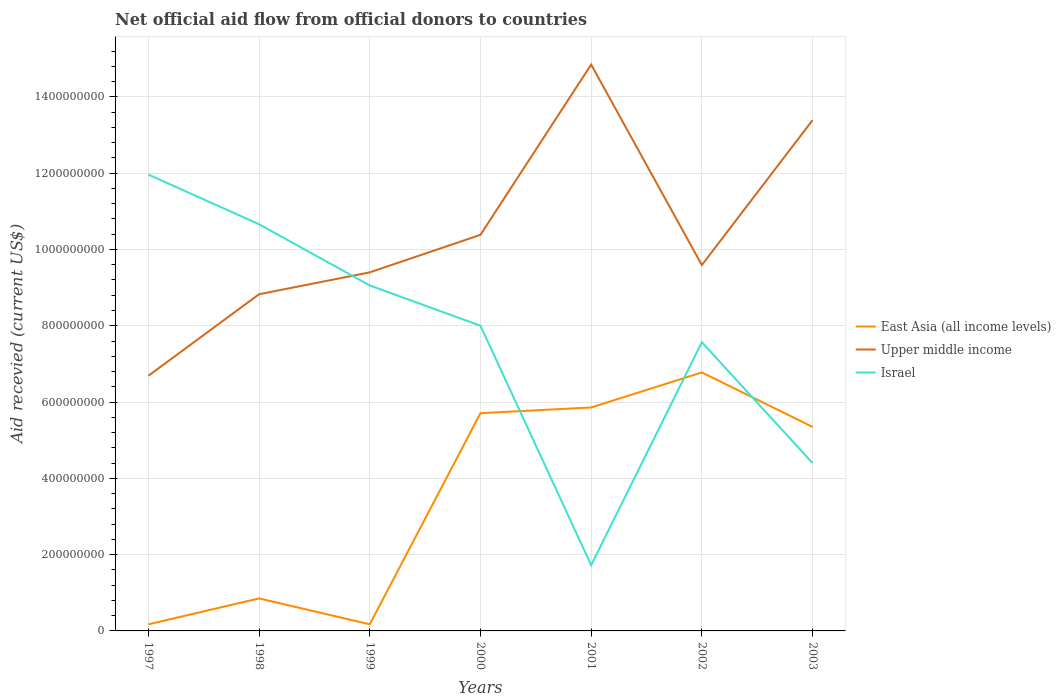How many different coloured lines are there?
Give a very brief answer. 3. Does the line corresponding to East Asia (all income levels) intersect with the line corresponding to Upper middle income?
Offer a terse response. No. Across all years, what is the maximum total aid received in Upper middle income?
Your answer should be very brief. 6.69e+08. What is the total total aid received in East Asia (all income levels) in the graph?
Give a very brief answer. -5.18e+08. What is the difference between the highest and the second highest total aid received in Upper middle income?
Offer a very short reply. 8.16e+08. What is the difference between the highest and the lowest total aid received in East Asia (all income levels)?
Your answer should be compact. 4. How many years are there in the graph?
Give a very brief answer. 7. What is the difference between two consecutive major ticks on the Y-axis?
Make the answer very short. 2.00e+08. Are the values on the major ticks of Y-axis written in scientific E-notation?
Offer a very short reply. No. Where does the legend appear in the graph?
Provide a succinct answer. Center right. What is the title of the graph?
Offer a very short reply. Net official aid flow from official donors to countries. Does "Haiti" appear as one of the legend labels in the graph?
Your answer should be compact. No. What is the label or title of the X-axis?
Give a very brief answer. Years. What is the label or title of the Y-axis?
Your answer should be compact. Aid recevied (current US$). What is the Aid recevied (current US$) of East Asia (all income levels) in 1997?
Keep it short and to the point. 1.73e+07. What is the Aid recevied (current US$) of Upper middle income in 1997?
Provide a succinct answer. 6.69e+08. What is the Aid recevied (current US$) in Israel in 1997?
Ensure brevity in your answer.  1.20e+09. What is the Aid recevied (current US$) of East Asia (all income levels) in 1998?
Ensure brevity in your answer.  8.52e+07. What is the Aid recevied (current US$) in Upper middle income in 1998?
Provide a succinct answer. 8.83e+08. What is the Aid recevied (current US$) of Israel in 1998?
Keep it short and to the point. 1.07e+09. What is the Aid recevied (current US$) of East Asia (all income levels) in 1999?
Keep it short and to the point. 1.74e+07. What is the Aid recevied (current US$) in Upper middle income in 1999?
Provide a short and direct response. 9.40e+08. What is the Aid recevied (current US$) of Israel in 1999?
Ensure brevity in your answer.  9.06e+08. What is the Aid recevied (current US$) in East Asia (all income levels) in 2000?
Give a very brief answer. 5.71e+08. What is the Aid recevied (current US$) of Upper middle income in 2000?
Your response must be concise. 1.04e+09. What is the Aid recevied (current US$) of Israel in 2000?
Make the answer very short. 8.00e+08. What is the Aid recevied (current US$) in East Asia (all income levels) in 2001?
Provide a short and direct response. 5.86e+08. What is the Aid recevied (current US$) in Upper middle income in 2001?
Provide a succinct answer. 1.48e+09. What is the Aid recevied (current US$) of Israel in 2001?
Your answer should be very brief. 1.72e+08. What is the Aid recevied (current US$) of East Asia (all income levels) in 2002?
Your response must be concise. 6.78e+08. What is the Aid recevied (current US$) in Upper middle income in 2002?
Ensure brevity in your answer.  9.59e+08. What is the Aid recevied (current US$) of Israel in 2002?
Your answer should be compact. 7.57e+08. What is the Aid recevied (current US$) in East Asia (all income levels) in 2003?
Provide a succinct answer. 5.35e+08. What is the Aid recevied (current US$) of Upper middle income in 2003?
Make the answer very short. 1.34e+09. What is the Aid recevied (current US$) of Israel in 2003?
Your answer should be very brief. 4.40e+08. Across all years, what is the maximum Aid recevied (current US$) in East Asia (all income levels)?
Offer a very short reply. 6.78e+08. Across all years, what is the maximum Aid recevied (current US$) in Upper middle income?
Offer a terse response. 1.48e+09. Across all years, what is the maximum Aid recevied (current US$) in Israel?
Keep it short and to the point. 1.20e+09. Across all years, what is the minimum Aid recevied (current US$) of East Asia (all income levels)?
Provide a succinct answer. 1.73e+07. Across all years, what is the minimum Aid recevied (current US$) in Upper middle income?
Provide a short and direct response. 6.69e+08. Across all years, what is the minimum Aid recevied (current US$) in Israel?
Your answer should be very brief. 1.72e+08. What is the total Aid recevied (current US$) in East Asia (all income levels) in the graph?
Your answer should be compact. 2.49e+09. What is the total Aid recevied (current US$) in Upper middle income in the graph?
Give a very brief answer. 7.31e+09. What is the total Aid recevied (current US$) in Israel in the graph?
Provide a succinct answer. 5.34e+09. What is the difference between the Aid recevied (current US$) in East Asia (all income levels) in 1997 and that in 1998?
Your response must be concise. -6.80e+07. What is the difference between the Aid recevied (current US$) of Upper middle income in 1997 and that in 1998?
Offer a very short reply. -2.14e+08. What is the difference between the Aid recevied (current US$) in Israel in 1997 and that in 1998?
Your response must be concise. 1.30e+08. What is the difference between the Aid recevied (current US$) of East Asia (all income levels) in 1997 and that in 1999?
Provide a short and direct response. -6.00e+04. What is the difference between the Aid recevied (current US$) in Upper middle income in 1997 and that in 1999?
Make the answer very short. -2.71e+08. What is the difference between the Aid recevied (current US$) in Israel in 1997 and that in 1999?
Offer a very short reply. 2.91e+08. What is the difference between the Aid recevied (current US$) of East Asia (all income levels) in 1997 and that in 2000?
Give a very brief answer. -5.54e+08. What is the difference between the Aid recevied (current US$) in Upper middle income in 1997 and that in 2000?
Give a very brief answer. -3.69e+08. What is the difference between the Aid recevied (current US$) in Israel in 1997 and that in 2000?
Offer a terse response. 3.96e+08. What is the difference between the Aid recevied (current US$) in East Asia (all income levels) in 1997 and that in 2001?
Ensure brevity in your answer.  -5.69e+08. What is the difference between the Aid recevied (current US$) of Upper middle income in 1997 and that in 2001?
Your response must be concise. -8.16e+08. What is the difference between the Aid recevied (current US$) in Israel in 1997 and that in 2001?
Provide a succinct answer. 1.02e+09. What is the difference between the Aid recevied (current US$) in East Asia (all income levels) in 1997 and that in 2002?
Make the answer very short. -6.60e+08. What is the difference between the Aid recevied (current US$) of Upper middle income in 1997 and that in 2002?
Offer a very short reply. -2.90e+08. What is the difference between the Aid recevied (current US$) in Israel in 1997 and that in 2002?
Offer a terse response. 4.39e+08. What is the difference between the Aid recevied (current US$) of East Asia (all income levels) in 1997 and that in 2003?
Keep it short and to the point. -5.18e+08. What is the difference between the Aid recevied (current US$) in Upper middle income in 1997 and that in 2003?
Offer a terse response. -6.70e+08. What is the difference between the Aid recevied (current US$) of Israel in 1997 and that in 2003?
Your response must be concise. 7.56e+08. What is the difference between the Aid recevied (current US$) in East Asia (all income levels) in 1998 and that in 1999?
Your answer should be very brief. 6.79e+07. What is the difference between the Aid recevied (current US$) in Upper middle income in 1998 and that in 1999?
Your response must be concise. -5.73e+07. What is the difference between the Aid recevied (current US$) of Israel in 1998 and that in 1999?
Your answer should be compact. 1.60e+08. What is the difference between the Aid recevied (current US$) in East Asia (all income levels) in 1998 and that in 2000?
Make the answer very short. -4.86e+08. What is the difference between the Aid recevied (current US$) in Upper middle income in 1998 and that in 2000?
Offer a terse response. -1.56e+08. What is the difference between the Aid recevied (current US$) in Israel in 1998 and that in 2000?
Make the answer very short. 2.66e+08. What is the difference between the Aid recevied (current US$) in East Asia (all income levels) in 1998 and that in 2001?
Provide a succinct answer. -5.01e+08. What is the difference between the Aid recevied (current US$) in Upper middle income in 1998 and that in 2001?
Your response must be concise. -6.02e+08. What is the difference between the Aid recevied (current US$) in Israel in 1998 and that in 2001?
Your response must be concise. 8.94e+08. What is the difference between the Aid recevied (current US$) of East Asia (all income levels) in 1998 and that in 2002?
Your answer should be very brief. -5.92e+08. What is the difference between the Aid recevied (current US$) of Upper middle income in 1998 and that in 2002?
Provide a short and direct response. -7.64e+07. What is the difference between the Aid recevied (current US$) of Israel in 1998 and that in 2002?
Give a very brief answer. 3.09e+08. What is the difference between the Aid recevied (current US$) in East Asia (all income levels) in 1998 and that in 2003?
Make the answer very short. -4.50e+08. What is the difference between the Aid recevied (current US$) in Upper middle income in 1998 and that in 2003?
Provide a short and direct response. -4.56e+08. What is the difference between the Aid recevied (current US$) of Israel in 1998 and that in 2003?
Your response must be concise. 6.26e+08. What is the difference between the Aid recevied (current US$) in East Asia (all income levels) in 1999 and that in 2000?
Your response must be concise. -5.53e+08. What is the difference between the Aid recevied (current US$) in Upper middle income in 1999 and that in 2000?
Give a very brief answer. -9.83e+07. What is the difference between the Aid recevied (current US$) in Israel in 1999 and that in 2000?
Provide a succinct answer. 1.06e+08. What is the difference between the Aid recevied (current US$) of East Asia (all income levels) in 1999 and that in 2001?
Offer a terse response. -5.68e+08. What is the difference between the Aid recevied (current US$) of Upper middle income in 1999 and that in 2001?
Your answer should be compact. -5.45e+08. What is the difference between the Aid recevied (current US$) in Israel in 1999 and that in 2001?
Offer a very short reply. 7.33e+08. What is the difference between the Aid recevied (current US$) in East Asia (all income levels) in 1999 and that in 2002?
Provide a succinct answer. -6.60e+08. What is the difference between the Aid recevied (current US$) of Upper middle income in 1999 and that in 2002?
Offer a terse response. -1.91e+07. What is the difference between the Aid recevied (current US$) of Israel in 1999 and that in 2002?
Your answer should be very brief. 1.49e+08. What is the difference between the Aid recevied (current US$) of East Asia (all income levels) in 1999 and that in 2003?
Keep it short and to the point. -5.18e+08. What is the difference between the Aid recevied (current US$) in Upper middle income in 1999 and that in 2003?
Make the answer very short. -3.99e+08. What is the difference between the Aid recevied (current US$) of Israel in 1999 and that in 2003?
Make the answer very short. 4.66e+08. What is the difference between the Aid recevied (current US$) in East Asia (all income levels) in 2000 and that in 2001?
Your response must be concise. -1.50e+07. What is the difference between the Aid recevied (current US$) in Upper middle income in 2000 and that in 2001?
Offer a very short reply. -4.46e+08. What is the difference between the Aid recevied (current US$) of Israel in 2000 and that in 2001?
Provide a succinct answer. 6.28e+08. What is the difference between the Aid recevied (current US$) in East Asia (all income levels) in 2000 and that in 2002?
Ensure brevity in your answer.  -1.07e+08. What is the difference between the Aid recevied (current US$) in Upper middle income in 2000 and that in 2002?
Offer a very short reply. 7.93e+07. What is the difference between the Aid recevied (current US$) in Israel in 2000 and that in 2002?
Offer a terse response. 4.31e+07. What is the difference between the Aid recevied (current US$) in East Asia (all income levels) in 2000 and that in 2003?
Ensure brevity in your answer.  3.59e+07. What is the difference between the Aid recevied (current US$) of Upper middle income in 2000 and that in 2003?
Make the answer very short. -3.01e+08. What is the difference between the Aid recevied (current US$) of Israel in 2000 and that in 2003?
Give a very brief answer. 3.60e+08. What is the difference between the Aid recevied (current US$) of East Asia (all income levels) in 2001 and that in 2002?
Make the answer very short. -9.18e+07. What is the difference between the Aid recevied (current US$) of Upper middle income in 2001 and that in 2002?
Provide a short and direct response. 5.26e+08. What is the difference between the Aid recevied (current US$) of Israel in 2001 and that in 2002?
Give a very brief answer. -5.85e+08. What is the difference between the Aid recevied (current US$) in East Asia (all income levels) in 2001 and that in 2003?
Offer a very short reply. 5.10e+07. What is the difference between the Aid recevied (current US$) in Upper middle income in 2001 and that in 2003?
Keep it short and to the point. 1.46e+08. What is the difference between the Aid recevied (current US$) in Israel in 2001 and that in 2003?
Your answer should be compact. -2.68e+08. What is the difference between the Aid recevied (current US$) in East Asia (all income levels) in 2002 and that in 2003?
Your answer should be compact. 1.43e+08. What is the difference between the Aid recevied (current US$) of Upper middle income in 2002 and that in 2003?
Your answer should be compact. -3.80e+08. What is the difference between the Aid recevied (current US$) of Israel in 2002 and that in 2003?
Your response must be concise. 3.17e+08. What is the difference between the Aid recevied (current US$) of East Asia (all income levels) in 1997 and the Aid recevied (current US$) of Upper middle income in 1998?
Provide a short and direct response. -8.65e+08. What is the difference between the Aid recevied (current US$) in East Asia (all income levels) in 1997 and the Aid recevied (current US$) in Israel in 1998?
Give a very brief answer. -1.05e+09. What is the difference between the Aid recevied (current US$) of Upper middle income in 1997 and the Aid recevied (current US$) of Israel in 1998?
Your answer should be very brief. -3.97e+08. What is the difference between the Aid recevied (current US$) of East Asia (all income levels) in 1997 and the Aid recevied (current US$) of Upper middle income in 1999?
Provide a succinct answer. -9.23e+08. What is the difference between the Aid recevied (current US$) in East Asia (all income levels) in 1997 and the Aid recevied (current US$) in Israel in 1999?
Your answer should be compact. -8.88e+08. What is the difference between the Aid recevied (current US$) of Upper middle income in 1997 and the Aid recevied (current US$) of Israel in 1999?
Ensure brevity in your answer.  -2.37e+08. What is the difference between the Aid recevied (current US$) of East Asia (all income levels) in 1997 and the Aid recevied (current US$) of Upper middle income in 2000?
Keep it short and to the point. -1.02e+09. What is the difference between the Aid recevied (current US$) of East Asia (all income levels) in 1997 and the Aid recevied (current US$) of Israel in 2000?
Give a very brief answer. -7.83e+08. What is the difference between the Aid recevied (current US$) in Upper middle income in 1997 and the Aid recevied (current US$) in Israel in 2000?
Ensure brevity in your answer.  -1.31e+08. What is the difference between the Aid recevied (current US$) of East Asia (all income levels) in 1997 and the Aid recevied (current US$) of Upper middle income in 2001?
Offer a terse response. -1.47e+09. What is the difference between the Aid recevied (current US$) in East Asia (all income levels) in 1997 and the Aid recevied (current US$) in Israel in 2001?
Give a very brief answer. -1.55e+08. What is the difference between the Aid recevied (current US$) in Upper middle income in 1997 and the Aid recevied (current US$) in Israel in 2001?
Provide a short and direct response. 4.97e+08. What is the difference between the Aid recevied (current US$) of East Asia (all income levels) in 1997 and the Aid recevied (current US$) of Upper middle income in 2002?
Keep it short and to the point. -9.42e+08. What is the difference between the Aid recevied (current US$) of East Asia (all income levels) in 1997 and the Aid recevied (current US$) of Israel in 2002?
Keep it short and to the point. -7.40e+08. What is the difference between the Aid recevied (current US$) in Upper middle income in 1997 and the Aid recevied (current US$) in Israel in 2002?
Your response must be concise. -8.79e+07. What is the difference between the Aid recevied (current US$) in East Asia (all income levels) in 1997 and the Aid recevied (current US$) in Upper middle income in 2003?
Ensure brevity in your answer.  -1.32e+09. What is the difference between the Aid recevied (current US$) of East Asia (all income levels) in 1997 and the Aid recevied (current US$) of Israel in 2003?
Your response must be concise. -4.23e+08. What is the difference between the Aid recevied (current US$) of Upper middle income in 1997 and the Aid recevied (current US$) of Israel in 2003?
Offer a very short reply. 2.29e+08. What is the difference between the Aid recevied (current US$) of East Asia (all income levels) in 1998 and the Aid recevied (current US$) of Upper middle income in 1999?
Your answer should be compact. -8.55e+08. What is the difference between the Aid recevied (current US$) in East Asia (all income levels) in 1998 and the Aid recevied (current US$) in Israel in 1999?
Offer a terse response. -8.20e+08. What is the difference between the Aid recevied (current US$) of Upper middle income in 1998 and the Aid recevied (current US$) of Israel in 1999?
Offer a very short reply. -2.31e+07. What is the difference between the Aid recevied (current US$) of East Asia (all income levels) in 1998 and the Aid recevied (current US$) of Upper middle income in 2000?
Your answer should be very brief. -9.53e+08. What is the difference between the Aid recevied (current US$) of East Asia (all income levels) in 1998 and the Aid recevied (current US$) of Israel in 2000?
Provide a succinct answer. -7.15e+08. What is the difference between the Aid recevied (current US$) in Upper middle income in 1998 and the Aid recevied (current US$) in Israel in 2000?
Provide a succinct answer. 8.26e+07. What is the difference between the Aid recevied (current US$) in East Asia (all income levels) in 1998 and the Aid recevied (current US$) in Upper middle income in 2001?
Offer a terse response. -1.40e+09. What is the difference between the Aid recevied (current US$) of East Asia (all income levels) in 1998 and the Aid recevied (current US$) of Israel in 2001?
Your answer should be very brief. -8.71e+07. What is the difference between the Aid recevied (current US$) of Upper middle income in 1998 and the Aid recevied (current US$) of Israel in 2001?
Your answer should be compact. 7.10e+08. What is the difference between the Aid recevied (current US$) in East Asia (all income levels) in 1998 and the Aid recevied (current US$) in Upper middle income in 2002?
Provide a succinct answer. -8.74e+08. What is the difference between the Aid recevied (current US$) of East Asia (all income levels) in 1998 and the Aid recevied (current US$) of Israel in 2002?
Keep it short and to the point. -6.72e+08. What is the difference between the Aid recevied (current US$) in Upper middle income in 1998 and the Aid recevied (current US$) in Israel in 2002?
Give a very brief answer. 1.26e+08. What is the difference between the Aid recevied (current US$) of East Asia (all income levels) in 1998 and the Aid recevied (current US$) of Upper middle income in 2003?
Keep it short and to the point. -1.25e+09. What is the difference between the Aid recevied (current US$) of East Asia (all income levels) in 1998 and the Aid recevied (current US$) of Israel in 2003?
Your response must be concise. -3.55e+08. What is the difference between the Aid recevied (current US$) of Upper middle income in 1998 and the Aid recevied (current US$) of Israel in 2003?
Provide a succinct answer. 4.43e+08. What is the difference between the Aid recevied (current US$) of East Asia (all income levels) in 1999 and the Aid recevied (current US$) of Upper middle income in 2000?
Ensure brevity in your answer.  -1.02e+09. What is the difference between the Aid recevied (current US$) of East Asia (all income levels) in 1999 and the Aid recevied (current US$) of Israel in 2000?
Give a very brief answer. -7.83e+08. What is the difference between the Aid recevied (current US$) of Upper middle income in 1999 and the Aid recevied (current US$) of Israel in 2000?
Make the answer very short. 1.40e+08. What is the difference between the Aid recevied (current US$) of East Asia (all income levels) in 1999 and the Aid recevied (current US$) of Upper middle income in 2001?
Keep it short and to the point. -1.47e+09. What is the difference between the Aid recevied (current US$) in East Asia (all income levels) in 1999 and the Aid recevied (current US$) in Israel in 2001?
Your response must be concise. -1.55e+08. What is the difference between the Aid recevied (current US$) in Upper middle income in 1999 and the Aid recevied (current US$) in Israel in 2001?
Provide a succinct answer. 7.68e+08. What is the difference between the Aid recevied (current US$) of East Asia (all income levels) in 1999 and the Aid recevied (current US$) of Upper middle income in 2002?
Make the answer very short. -9.42e+08. What is the difference between the Aid recevied (current US$) of East Asia (all income levels) in 1999 and the Aid recevied (current US$) of Israel in 2002?
Give a very brief answer. -7.40e+08. What is the difference between the Aid recevied (current US$) of Upper middle income in 1999 and the Aid recevied (current US$) of Israel in 2002?
Your answer should be compact. 1.83e+08. What is the difference between the Aid recevied (current US$) in East Asia (all income levels) in 1999 and the Aid recevied (current US$) in Upper middle income in 2003?
Offer a very short reply. -1.32e+09. What is the difference between the Aid recevied (current US$) in East Asia (all income levels) in 1999 and the Aid recevied (current US$) in Israel in 2003?
Your response must be concise. -4.23e+08. What is the difference between the Aid recevied (current US$) in Upper middle income in 1999 and the Aid recevied (current US$) in Israel in 2003?
Make the answer very short. 5.00e+08. What is the difference between the Aid recevied (current US$) in East Asia (all income levels) in 2000 and the Aid recevied (current US$) in Upper middle income in 2001?
Your answer should be very brief. -9.14e+08. What is the difference between the Aid recevied (current US$) in East Asia (all income levels) in 2000 and the Aid recevied (current US$) in Israel in 2001?
Offer a very short reply. 3.98e+08. What is the difference between the Aid recevied (current US$) of Upper middle income in 2000 and the Aid recevied (current US$) of Israel in 2001?
Your answer should be very brief. 8.66e+08. What is the difference between the Aid recevied (current US$) of East Asia (all income levels) in 2000 and the Aid recevied (current US$) of Upper middle income in 2002?
Ensure brevity in your answer.  -3.88e+08. What is the difference between the Aid recevied (current US$) of East Asia (all income levels) in 2000 and the Aid recevied (current US$) of Israel in 2002?
Your answer should be compact. -1.86e+08. What is the difference between the Aid recevied (current US$) in Upper middle income in 2000 and the Aid recevied (current US$) in Israel in 2002?
Make the answer very short. 2.81e+08. What is the difference between the Aid recevied (current US$) in East Asia (all income levels) in 2000 and the Aid recevied (current US$) in Upper middle income in 2003?
Provide a short and direct response. -7.68e+08. What is the difference between the Aid recevied (current US$) in East Asia (all income levels) in 2000 and the Aid recevied (current US$) in Israel in 2003?
Offer a very short reply. 1.31e+08. What is the difference between the Aid recevied (current US$) in Upper middle income in 2000 and the Aid recevied (current US$) in Israel in 2003?
Provide a short and direct response. 5.98e+08. What is the difference between the Aid recevied (current US$) of East Asia (all income levels) in 2001 and the Aid recevied (current US$) of Upper middle income in 2002?
Give a very brief answer. -3.73e+08. What is the difference between the Aid recevied (current US$) in East Asia (all income levels) in 2001 and the Aid recevied (current US$) in Israel in 2002?
Give a very brief answer. -1.71e+08. What is the difference between the Aid recevied (current US$) in Upper middle income in 2001 and the Aid recevied (current US$) in Israel in 2002?
Your answer should be very brief. 7.28e+08. What is the difference between the Aid recevied (current US$) in East Asia (all income levels) in 2001 and the Aid recevied (current US$) in Upper middle income in 2003?
Your response must be concise. -7.53e+08. What is the difference between the Aid recevied (current US$) of East Asia (all income levels) in 2001 and the Aid recevied (current US$) of Israel in 2003?
Keep it short and to the point. 1.46e+08. What is the difference between the Aid recevied (current US$) of Upper middle income in 2001 and the Aid recevied (current US$) of Israel in 2003?
Provide a short and direct response. 1.04e+09. What is the difference between the Aid recevied (current US$) in East Asia (all income levels) in 2002 and the Aid recevied (current US$) in Upper middle income in 2003?
Your answer should be compact. -6.61e+08. What is the difference between the Aid recevied (current US$) of East Asia (all income levels) in 2002 and the Aid recevied (current US$) of Israel in 2003?
Your answer should be compact. 2.38e+08. What is the difference between the Aid recevied (current US$) in Upper middle income in 2002 and the Aid recevied (current US$) in Israel in 2003?
Offer a very short reply. 5.19e+08. What is the average Aid recevied (current US$) of East Asia (all income levels) per year?
Give a very brief answer. 3.56e+08. What is the average Aid recevied (current US$) in Upper middle income per year?
Offer a very short reply. 1.04e+09. What is the average Aid recevied (current US$) in Israel per year?
Your answer should be very brief. 7.62e+08. In the year 1997, what is the difference between the Aid recevied (current US$) of East Asia (all income levels) and Aid recevied (current US$) of Upper middle income?
Make the answer very short. -6.52e+08. In the year 1997, what is the difference between the Aid recevied (current US$) of East Asia (all income levels) and Aid recevied (current US$) of Israel?
Give a very brief answer. -1.18e+09. In the year 1997, what is the difference between the Aid recevied (current US$) in Upper middle income and Aid recevied (current US$) in Israel?
Ensure brevity in your answer.  -5.27e+08. In the year 1998, what is the difference between the Aid recevied (current US$) in East Asia (all income levels) and Aid recevied (current US$) in Upper middle income?
Provide a short and direct response. -7.97e+08. In the year 1998, what is the difference between the Aid recevied (current US$) of East Asia (all income levels) and Aid recevied (current US$) of Israel?
Offer a very short reply. -9.81e+08. In the year 1998, what is the difference between the Aid recevied (current US$) of Upper middle income and Aid recevied (current US$) of Israel?
Make the answer very short. -1.83e+08. In the year 1999, what is the difference between the Aid recevied (current US$) of East Asia (all income levels) and Aid recevied (current US$) of Upper middle income?
Your answer should be compact. -9.23e+08. In the year 1999, what is the difference between the Aid recevied (current US$) in East Asia (all income levels) and Aid recevied (current US$) in Israel?
Keep it short and to the point. -8.88e+08. In the year 1999, what is the difference between the Aid recevied (current US$) of Upper middle income and Aid recevied (current US$) of Israel?
Your answer should be compact. 3.43e+07. In the year 2000, what is the difference between the Aid recevied (current US$) in East Asia (all income levels) and Aid recevied (current US$) in Upper middle income?
Offer a very short reply. -4.68e+08. In the year 2000, what is the difference between the Aid recevied (current US$) of East Asia (all income levels) and Aid recevied (current US$) of Israel?
Keep it short and to the point. -2.29e+08. In the year 2000, what is the difference between the Aid recevied (current US$) in Upper middle income and Aid recevied (current US$) in Israel?
Provide a short and direct response. 2.38e+08. In the year 2001, what is the difference between the Aid recevied (current US$) of East Asia (all income levels) and Aid recevied (current US$) of Upper middle income?
Your answer should be compact. -8.99e+08. In the year 2001, what is the difference between the Aid recevied (current US$) in East Asia (all income levels) and Aid recevied (current US$) in Israel?
Ensure brevity in your answer.  4.13e+08. In the year 2001, what is the difference between the Aid recevied (current US$) in Upper middle income and Aid recevied (current US$) in Israel?
Provide a short and direct response. 1.31e+09. In the year 2002, what is the difference between the Aid recevied (current US$) in East Asia (all income levels) and Aid recevied (current US$) in Upper middle income?
Your answer should be very brief. -2.81e+08. In the year 2002, what is the difference between the Aid recevied (current US$) of East Asia (all income levels) and Aid recevied (current US$) of Israel?
Offer a terse response. -7.93e+07. In the year 2002, what is the difference between the Aid recevied (current US$) in Upper middle income and Aid recevied (current US$) in Israel?
Your response must be concise. 2.02e+08. In the year 2003, what is the difference between the Aid recevied (current US$) in East Asia (all income levels) and Aid recevied (current US$) in Upper middle income?
Your answer should be very brief. -8.04e+08. In the year 2003, what is the difference between the Aid recevied (current US$) of East Asia (all income levels) and Aid recevied (current US$) of Israel?
Offer a terse response. 9.49e+07. In the year 2003, what is the difference between the Aid recevied (current US$) in Upper middle income and Aid recevied (current US$) in Israel?
Your response must be concise. 8.99e+08. What is the ratio of the Aid recevied (current US$) in East Asia (all income levels) in 1997 to that in 1998?
Give a very brief answer. 0.2. What is the ratio of the Aid recevied (current US$) of Upper middle income in 1997 to that in 1998?
Provide a short and direct response. 0.76. What is the ratio of the Aid recevied (current US$) in Israel in 1997 to that in 1998?
Provide a succinct answer. 1.12. What is the ratio of the Aid recevied (current US$) in Upper middle income in 1997 to that in 1999?
Your answer should be very brief. 0.71. What is the ratio of the Aid recevied (current US$) in Israel in 1997 to that in 1999?
Keep it short and to the point. 1.32. What is the ratio of the Aid recevied (current US$) in East Asia (all income levels) in 1997 to that in 2000?
Your response must be concise. 0.03. What is the ratio of the Aid recevied (current US$) of Upper middle income in 1997 to that in 2000?
Ensure brevity in your answer.  0.64. What is the ratio of the Aid recevied (current US$) in Israel in 1997 to that in 2000?
Your answer should be very brief. 1.5. What is the ratio of the Aid recevied (current US$) of East Asia (all income levels) in 1997 to that in 2001?
Your response must be concise. 0.03. What is the ratio of the Aid recevied (current US$) in Upper middle income in 1997 to that in 2001?
Keep it short and to the point. 0.45. What is the ratio of the Aid recevied (current US$) of Israel in 1997 to that in 2001?
Your answer should be compact. 6.94. What is the ratio of the Aid recevied (current US$) in East Asia (all income levels) in 1997 to that in 2002?
Provide a short and direct response. 0.03. What is the ratio of the Aid recevied (current US$) of Upper middle income in 1997 to that in 2002?
Your answer should be compact. 0.7. What is the ratio of the Aid recevied (current US$) in Israel in 1997 to that in 2002?
Give a very brief answer. 1.58. What is the ratio of the Aid recevied (current US$) in East Asia (all income levels) in 1997 to that in 2003?
Give a very brief answer. 0.03. What is the ratio of the Aid recevied (current US$) of Upper middle income in 1997 to that in 2003?
Give a very brief answer. 0.5. What is the ratio of the Aid recevied (current US$) of Israel in 1997 to that in 2003?
Your response must be concise. 2.72. What is the ratio of the Aid recevied (current US$) of East Asia (all income levels) in 1998 to that in 1999?
Offer a very short reply. 4.91. What is the ratio of the Aid recevied (current US$) of Upper middle income in 1998 to that in 1999?
Your response must be concise. 0.94. What is the ratio of the Aid recevied (current US$) in Israel in 1998 to that in 1999?
Keep it short and to the point. 1.18. What is the ratio of the Aid recevied (current US$) in East Asia (all income levels) in 1998 to that in 2000?
Make the answer very short. 0.15. What is the ratio of the Aid recevied (current US$) of Upper middle income in 1998 to that in 2000?
Your answer should be very brief. 0.85. What is the ratio of the Aid recevied (current US$) of Israel in 1998 to that in 2000?
Ensure brevity in your answer.  1.33. What is the ratio of the Aid recevied (current US$) in East Asia (all income levels) in 1998 to that in 2001?
Provide a succinct answer. 0.15. What is the ratio of the Aid recevied (current US$) of Upper middle income in 1998 to that in 2001?
Provide a short and direct response. 0.59. What is the ratio of the Aid recevied (current US$) in Israel in 1998 to that in 2001?
Your response must be concise. 6.19. What is the ratio of the Aid recevied (current US$) of East Asia (all income levels) in 1998 to that in 2002?
Provide a succinct answer. 0.13. What is the ratio of the Aid recevied (current US$) in Upper middle income in 1998 to that in 2002?
Offer a very short reply. 0.92. What is the ratio of the Aid recevied (current US$) in Israel in 1998 to that in 2002?
Offer a very short reply. 1.41. What is the ratio of the Aid recevied (current US$) in East Asia (all income levels) in 1998 to that in 2003?
Provide a short and direct response. 0.16. What is the ratio of the Aid recevied (current US$) of Upper middle income in 1998 to that in 2003?
Offer a very short reply. 0.66. What is the ratio of the Aid recevied (current US$) of Israel in 1998 to that in 2003?
Offer a terse response. 2.42. What is the ratio of the Aid recevied (current US$) of East Asia (all income levels) in 1999 to that in 2000?
Give a very brief answer. 0.03. What is the ratio of the Aid recevied (current US$) in Upper middle income in 1999 to that in 2000?
Keep it short and to the point. 0.91. What is the ratio of the Aid recevied (current US$) in Israel in 1999 to that in 2000?
Your answer should be compact. 1.13. What is the ratio of the Aid recevied (current US$) of East Asia (all income levels) in 1999 to that in 2001?
Ensure brevity in your answer.  0.03. What is the ratio of the Aid recevied (current US$) of Upper middle income in 1999 to that in 2001?
Keep it short and to the point. 0.63. What is the ratio of the Aid recevied (current US$) in Israel in 1999 to that in 2001?
Provide a succinct answer. 5.26. What is the ratio of the Aid recevied (current US$) of East Asia (all income levels) in 1999 to that in 2002?
Ensure brevity in your answer.  0.03. What is the ratio of the Aid recevied (current US$) in Upper middle income in 1999 to that in 2002?
Your response must be concise. 0.98. What is the ratio of the Aid recevied (current US$) of Israel in 1999 to that in 2002?
Provide a short and direct response. 1.2. What is the ratio of the Aid recevied (current US$) in East Asia (all income levels) in 1999 to that in 2003?
Provide a short and direct response. 0.03. What is the ratio of the Aid recevied (current US$) in Upper middle income in 1999 to that in 2003?
Your answer should be very brief. 0.7. What is the ratio of the Aid recevied (current US$) of Israel in 1999 to that in 2003?
Make the answer very short. 2.06. What is the ratio of the Aid recevied (current US$) of East Asia (all income levels) in 2000 to that in 2001?
Provide a succinct answer. 0.97. What is the ratio of the Aid recevied (current US$) in Upper middle income in 2000 to that in 2001?
Keep it short and to the point. 0.7. What is the ratio of the Aid recevied (current US$) in Israel in 2000 to that in 2001?
Provide a short and direct response. 4.64. What is the ratio of the Aid recevied (current US$) of East Asia (all income levels) in 2000 to that in 2002?
Provide a succinct answer. 0.84. What is the ratio of the Aid recevied (current US$) in Upper middle income in 2000 to that in 2002?
Provide a succinct answer. 1.08. What is the ratio of the Aid recevied (current US$) of Israel in 2000 to that in 2002?
Your answer should be compact. 1.06. What is the ratio of the Aid recevied (current US$) in East Asia (all income levels) in 2000 to that in 2003?
Give a very brief answer. 1.07. What is the ratio of the Aid recevied (current US$) of Upper middle income in 2000 to that in 2003?
Keep it short and to the point. 0.78. What is the ratio of the Aid recevied (current US$) of Israel in 2000 to that in 2003?
Ensure brevity in your answer.  1.82. What is the ratio of the Aid recevied (current US$) in East Asia (all income levels) in 2001 to that in 2002?
Give a very brief answer. 0.86. What is the ratio of the Aid recevied (current US$) in Upper middle income in 2001 to that in 2002?
Provide a succinct answer. 1.55. What is the ratio of the Aid recevied (current US$) in Israel in 2001 to that in 2002?
Give a very brief answer. 0.23. What is the ratio of the Aid recevied (current US$) of East Asia (all income levels) in 2001 to that in 2003?
Provide a succinct answer. 1.1. What is the ratio of the Aid recevied (current US$) of Upper middle income in 2001 to that in 2003?
Your response must be concise. 1.11. What is the ratio of the Aid recevied (current US$) in Israel in 2001 to that in 2003?
Your answer should be compact. 0.39. What is the ratio of the Aid recevied (current US$) of East Asia (all income levels) in 2002 to that in 2003?
Keep it short and to the point. 1.27. What is the ratio of the Aid recevied (current US$) of Upper middle income in 2002 to that in 2003?
Your answer should be very brief. 0.72. What is the ratio of the Aid recevied (current US$) of Israel in 2002 to that in 2003?
Offer a terse response. 1.72. What is the difference between the highest and the second highest Aid recevied (current US$) of East Asia (all income levels)?
Offer a terse response. 9.18e+07. What is the difference between the highest and the second highest Aid recevied (current US$) in Upper middle income?
Provide a succinct answer. 1.46e+08. What is the difference between the highest and the second highest Aid recevied (current US$) in Israel?
Your answer should be very brief. 1.30e+08. What is the difference between the highest and the lowest Aid recevied (current US$) of East Asia (all income levels)?
Offer a very short reply. 6.60e+08. What is the difference between the highest and the lowest Aid recevied (current US$) in Upper middle income?
Give a very brief answer. 8.16e+08. What is the difference between the highest and the lowest Aid recevied (current US$) in Israel?
Give a very brief answer. 1.02e+09. 